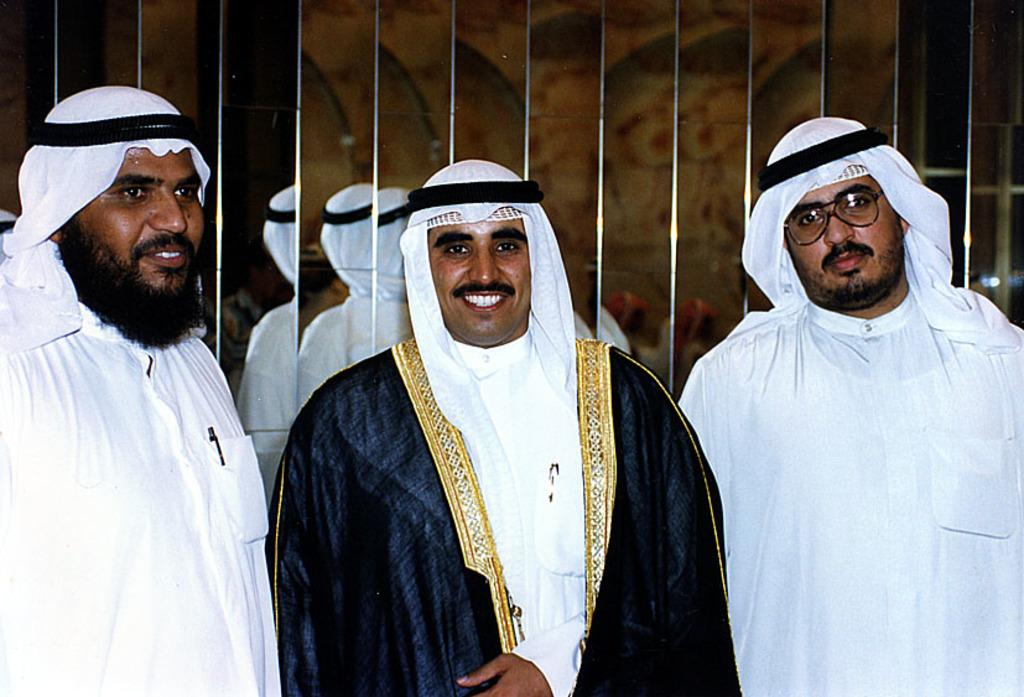How many people are in the image? There are three men in the image. What are the men doing in the image? The men are standing and smiling. What can be seen in the background of the image? There are mirrored walls in the background of the image. Can you see any monkeys playing with a rose in the image? No, there are no monkeys or roses present in the image. 